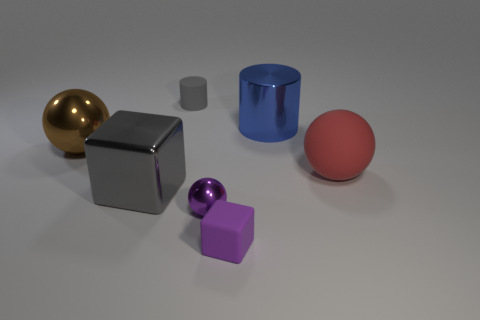The rubber thing that is the same size as the blue metallic cylinder is what shape?
Your response must be concise. Sphere. What number of small rubber objects are the same color as the large matte thing?
Ensure brevity in your answer.  0. What size is the purple object to the left of the matte block?
Offer a terse response. Small. What number of other purple blocks have the same size as the rubber block?
Your response must be concise. 0. There is a small block that is the same material as the large red object; what is its color?
Provide a short and direct response. Purple. Are there fewer big cubes behind the blue shiny object than large green rubber cylinders?
Your response must be concise. No. There is a gray object that is made of the same material as the small purple ball; what shape is it?
Offer a very short reply. Cube. How many metal objects are tiny blue cylinders or tiny blocks?
Your answer should be compact. 0. Are there an equal number of shiny things on the left side of the large brown sphere and tiny green cylinders?
Offer a very short reply. Yes. There is a block right of the large metal block; does it have the same color as the tiny metallic sphere?
Keep it short and to the point. Yes. 